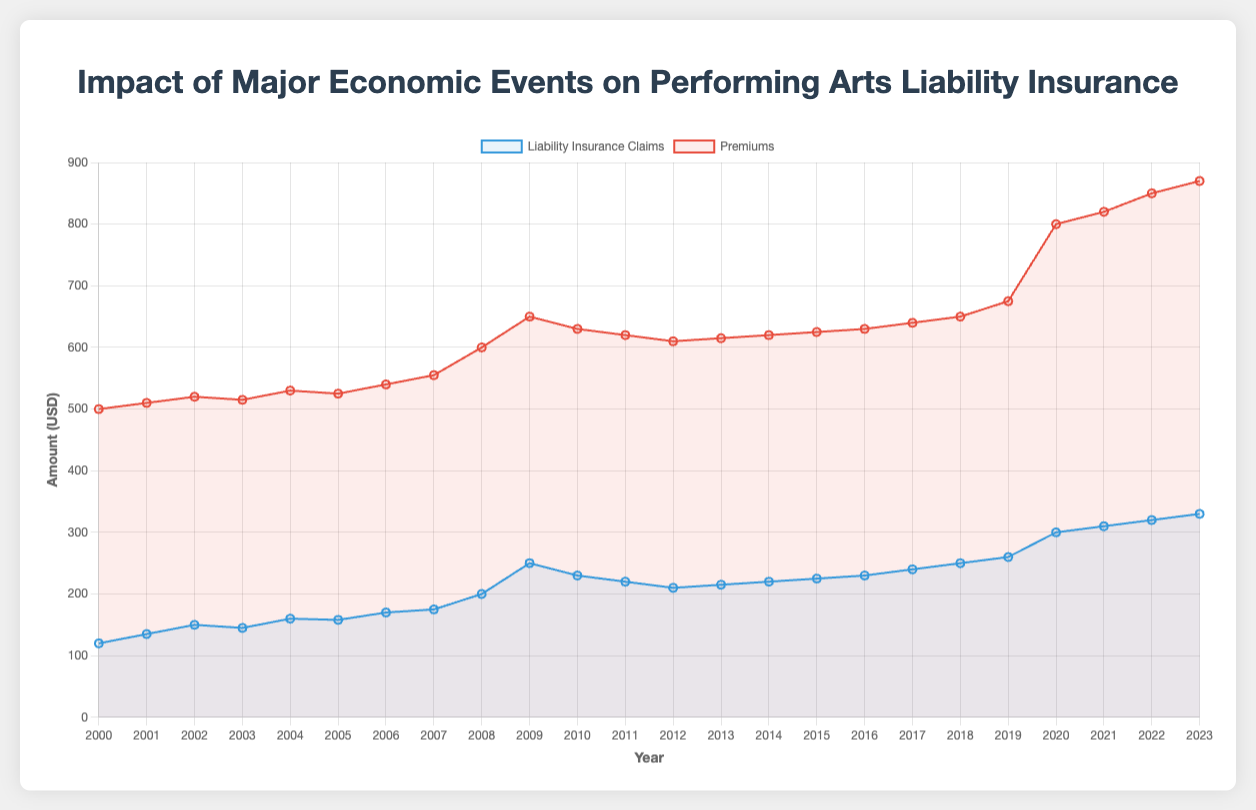What economic event occurred in 2008 and how did it affect the claims and premiums? The 2008 event was the US Housing Market Crash. Following this event, liability insurance claims rose significantly from 175 to 200, and premiums increased from 555 to 600.
Answer: US Housing Market Crash; claims increased by 25, premiums increased by 45 How did liability insurance claims and premiums change during the Great Recession (2008-2009)? During the Great Recession, claims increased from 200 to 250, and premiums rose from 600 to 650, reflecting a 50-unit increase in claims and a 50-unit increase in premiums.
Answer: Claims +50, Premiums +50 Which year experienced the highest increase in liability insurance claims and what was the event? In 2008, during the US Housing Market Crash, claims increased significantly by 25 units, the highest in a single year observed on the chart.
Answer: 2008; US Housing Market Crash Compare the trend lines for 2020 and 2021. How did COVID-19 impact both claims and premiums? In 2020, the COVID-19 Outbreak caused a substantial spike, increasing claims from 260 to 300 and premiums from 675 to 800. In 2021, with COVID-19 Variants Surge, claims increased slightly to 310 and premiums to 820. Both years saw significant increases, with 2020 having a greater impact.
Answer: Claims +40, Premiums +125 in 2020; Claims +10, Premiums +20 in 2021 Which year saw the smallest increase or a decrease in premiums and what was the corresponding economic event? The year 2002, marked by the Enron Scandal, saw the smallest increase in premiums, with an increase of just 10 units from 520 to 515 (a slight regression).
Answer: 2002, Enron Scandal What's the overall trend in liability insurance claims from 2000 to 2023? The overall trend shows a steady increase in liability insurance claims from 120 in 2000 to 330 in 2023, with periods of larger increments during significant economic events.
Answer: Increasing trend How does the year 2016 compare to 2023 in terms of premiums and claims? In 2016, claims were at 230 and premiums at 630. By 2023, claims increased to 330 and premiums to 870. This shows an increase in claims by 100 and premiums by 240 units.
Answer: Claims +100, Premiums +240 Which economic event appears to have had the least impact on premiums? The Enron Scandal in 2002 had the least impact on premiums, with a minimal increase from 520 to 515.
Answer: Enron Scandal (2002) What is the average increase in premiums following major economic events from 2000 to 2023? Calculating the average increase: [(510-500) + (520-510) + (515-520) + (530-515) + (525-530) + (540-525) + (555-540) + (600-555) + (650-600) + (630-650) + (620-630) + (610-620) + (615-610) + (620-615) + (625-620) + (630-625) + (640-630) + (650-640) + (675-650) + (800-675) + (820-800) + (850-820) + (870-850)] / 23 = 15. Averages are rounded to nearest unit, giving 13.05 which rounds to 13.
Answer: 13 